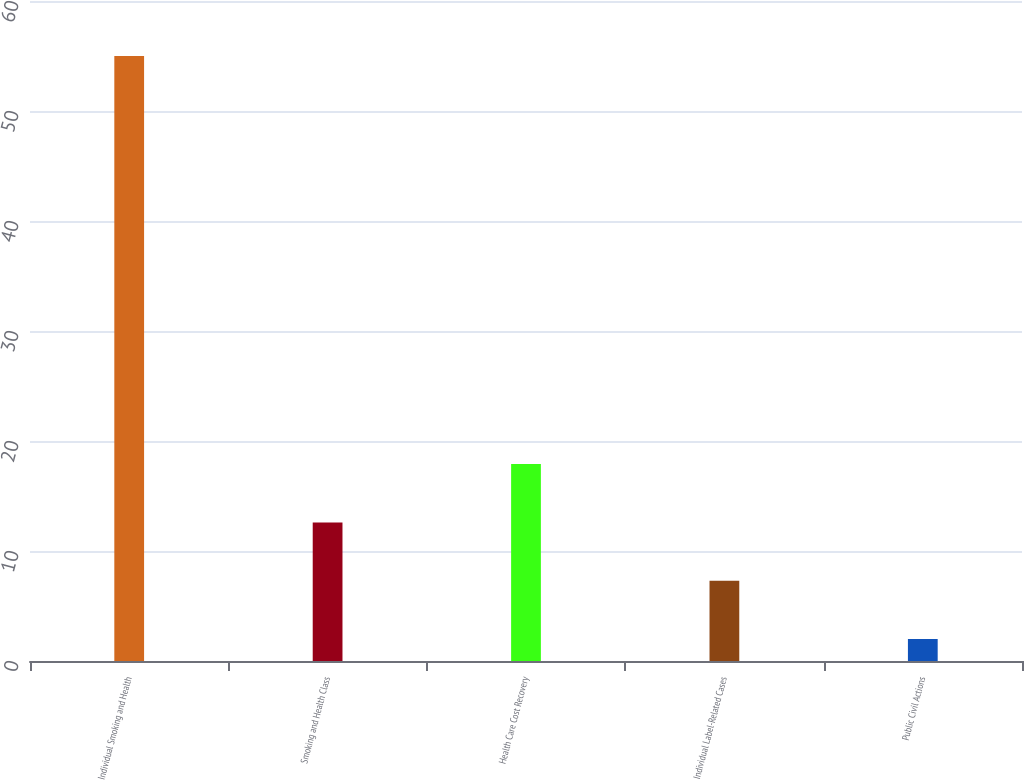Convert chart. <chart><loc_0><loc_0><loc_500><loc_500><bar_chart><fcel>Individual Smoking and Health<fcel>Smoking and Health Class<fcel>Health Care Cost Recovery<fcel>Individual Label-Related Cases<fcel>Public Civil Actions<nl><fcel>55<fcel>12.6<fcel>17.9<fcel>7.3<fcel>2<nl></chart> 